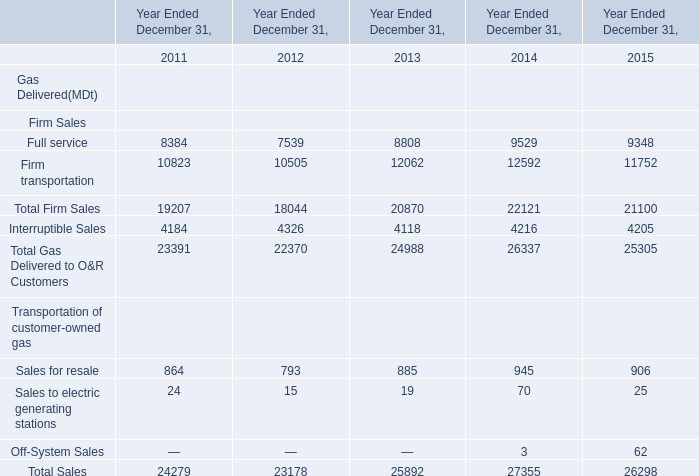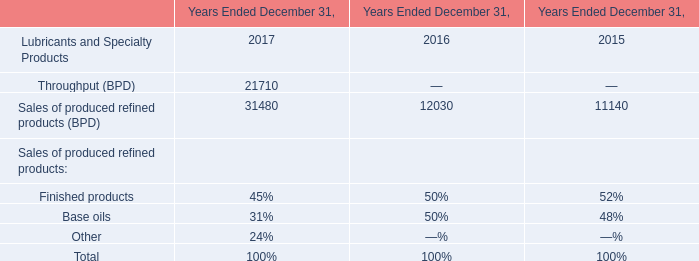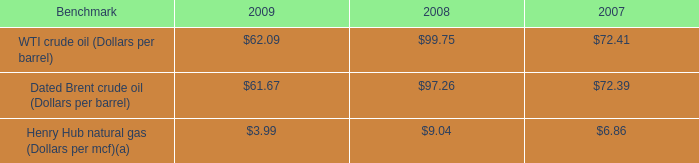What is the sum of the Gas Delivered to O&R Customers in the years where total firm sales is greater than 22000? 
Computations: ((9529 + 12592) + 4216)
Answer: 26337.0. 